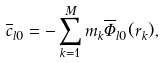Convert formula to latex. <formula><loc_0><loc_0><loc_500><loc_500>\overline { c } _ { l 0 } = - \sum _ { k = 1 } ^ { M } m _ { k } \overline { \Phi } _ { l 0 } ( { r } _ { k } ) ,</formula> 